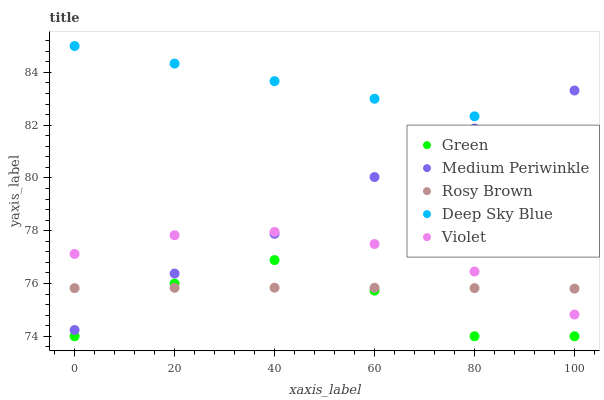Does Green have the minimum area under the curve?
Answer yes or no. Yes. Does Deep Sky Blue have the maximum area under the curve?
Answer yes or no. Yes. Does Rosy Brown have the minimum area under the curve?
Answer yes or no. No. Does Rosy Brown have the maximum area under the curve?
Answer yes or no. No. Is Deep Sky Blue the smoothest?
Answer yes or no. Yes. Is Green the roughest?
Answer yes or no. Yes. Is Rosy Brown the smoothest?
Answer yes or no. No. Is Rosy Brown the roughest?
Answer yes or no. No. Does Green have the lowest value?
Answer yes or no. Yes. Does Rosy Brown have the lowest value?
Answer yes or no. No. Does Deep Sky Blue have the highest value?
Answer yes or no. Yes. Does Green have the highest value?
Answer yes or no. No. Is Green less than Medium Periwinkle?
Answer yes or no. Yes. Is Deep Sky Blue greater than Green?
Answer yes or no. Yes. Does Deep Sky Blue intersect Medium Periwinkle?
Answer yes or no. Yes. Is Deep Sky Blue less than Medium Periwinkle?
Answer yes or no. No. Is Deep Sky Blue greater than Medium Periwinkle?
Answer yes or no. No. Does Green intersect Medium Periwinkle?
Answer yes or no. No. 